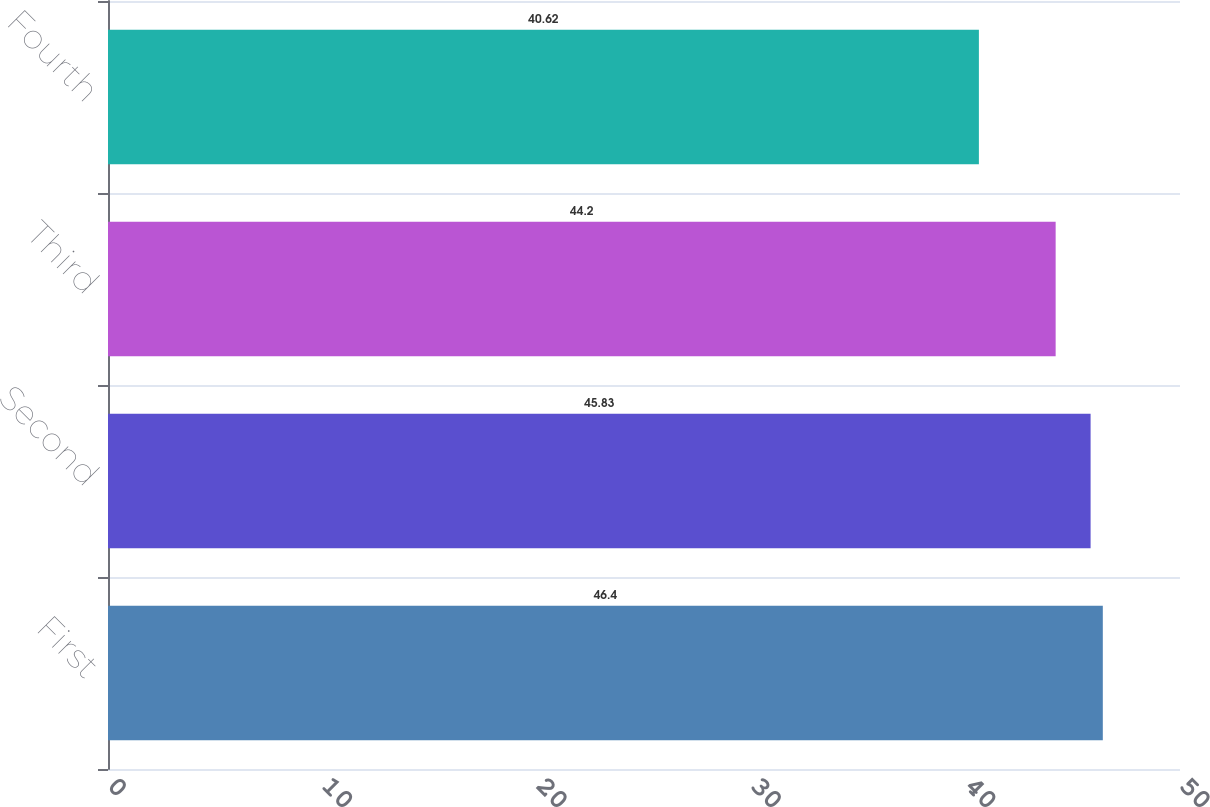Convert chart to OTSL. <chart><loc_0><loc_0><loc_500><loc_500><bar_chart><fcel>First<fcel>Second<fcel>Third<fcel>Fourth<nl><fcel>46.4<fcel>45.83<fcel>44.2<fcel>40.62<nl></chart> 